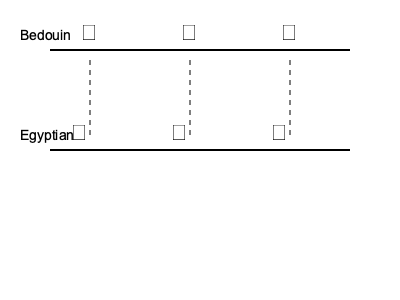Match the Bedouin tribal symbols to their corresponding Ancient Egyptian hieroglyphs based on their shared cultural significance. Which pair represents the concept of water or liquid? To answer this question, we need to analyze the symbols and their meanings in both Bedouin and Ancient Egyptian cultures:

1. The first pair: 
   - Bedouin symbol: ☽ (crescent moon)
   - Egyptian hieroglyph: 𓃀 (jackal)
   These symbols are not related to water or liquid.

2. The second pair:
   - Bedouin symbol: ✹ (star)
   - Egyptian hieroglyph: 𓇼 (sun with rays)
   These symbols are associated with celestial bodies but not water.

3. The third pair:
   - Bedouin symbol: ⋈ (hourglass shape)
   - Egyptian hieroglyph: 𓈗 (three wavy lines)
   
   This pair represents water or liquid:
   - In Bedouin culture, the hourglass shape ⋈ often symbolizes an oasis or water source, which is crucial for desert survival.
   - In Ancient Egyptian hieroglyphs, the three wavy lines 𓈗 represent water, rivers, or any liquid.

Both symbols convey the concept of water, which is essential in desert cultures like the Bedouins and Ancient Egyptians.
Answer: ⋈ and 𓈗 